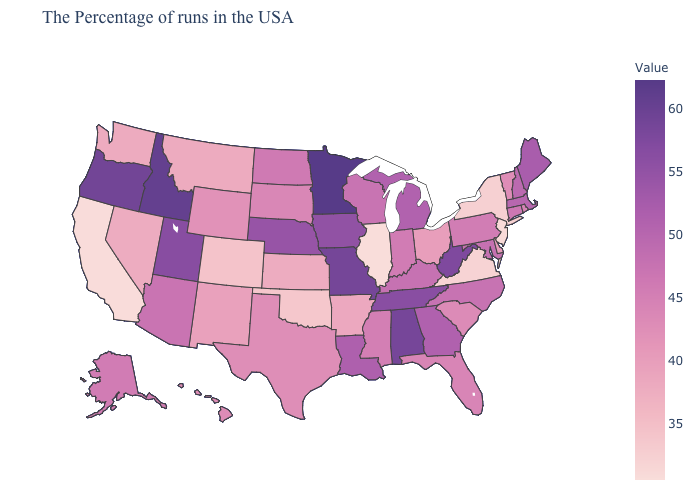Does the map have missing data?
Concise answer only. No. Which states have the lowest value in the USA?
Keep it brief. Illinois. Does Illinois have the lowest value in the USA?
Write a very short answer. Yes. Which states have the lowest value in the USA?
Write a very short answer. Illinois. Which states have the lowest value in the USA?
Concise answer only. Illinois. Does Illinois have the lowest value in the USA?
Keep it brief. Yes. Among the states that border Utah , does Colorado have the lowest value?
Short answer required. Yes. Which states have the lowest value in the South?
Be succinct. Virginia. 